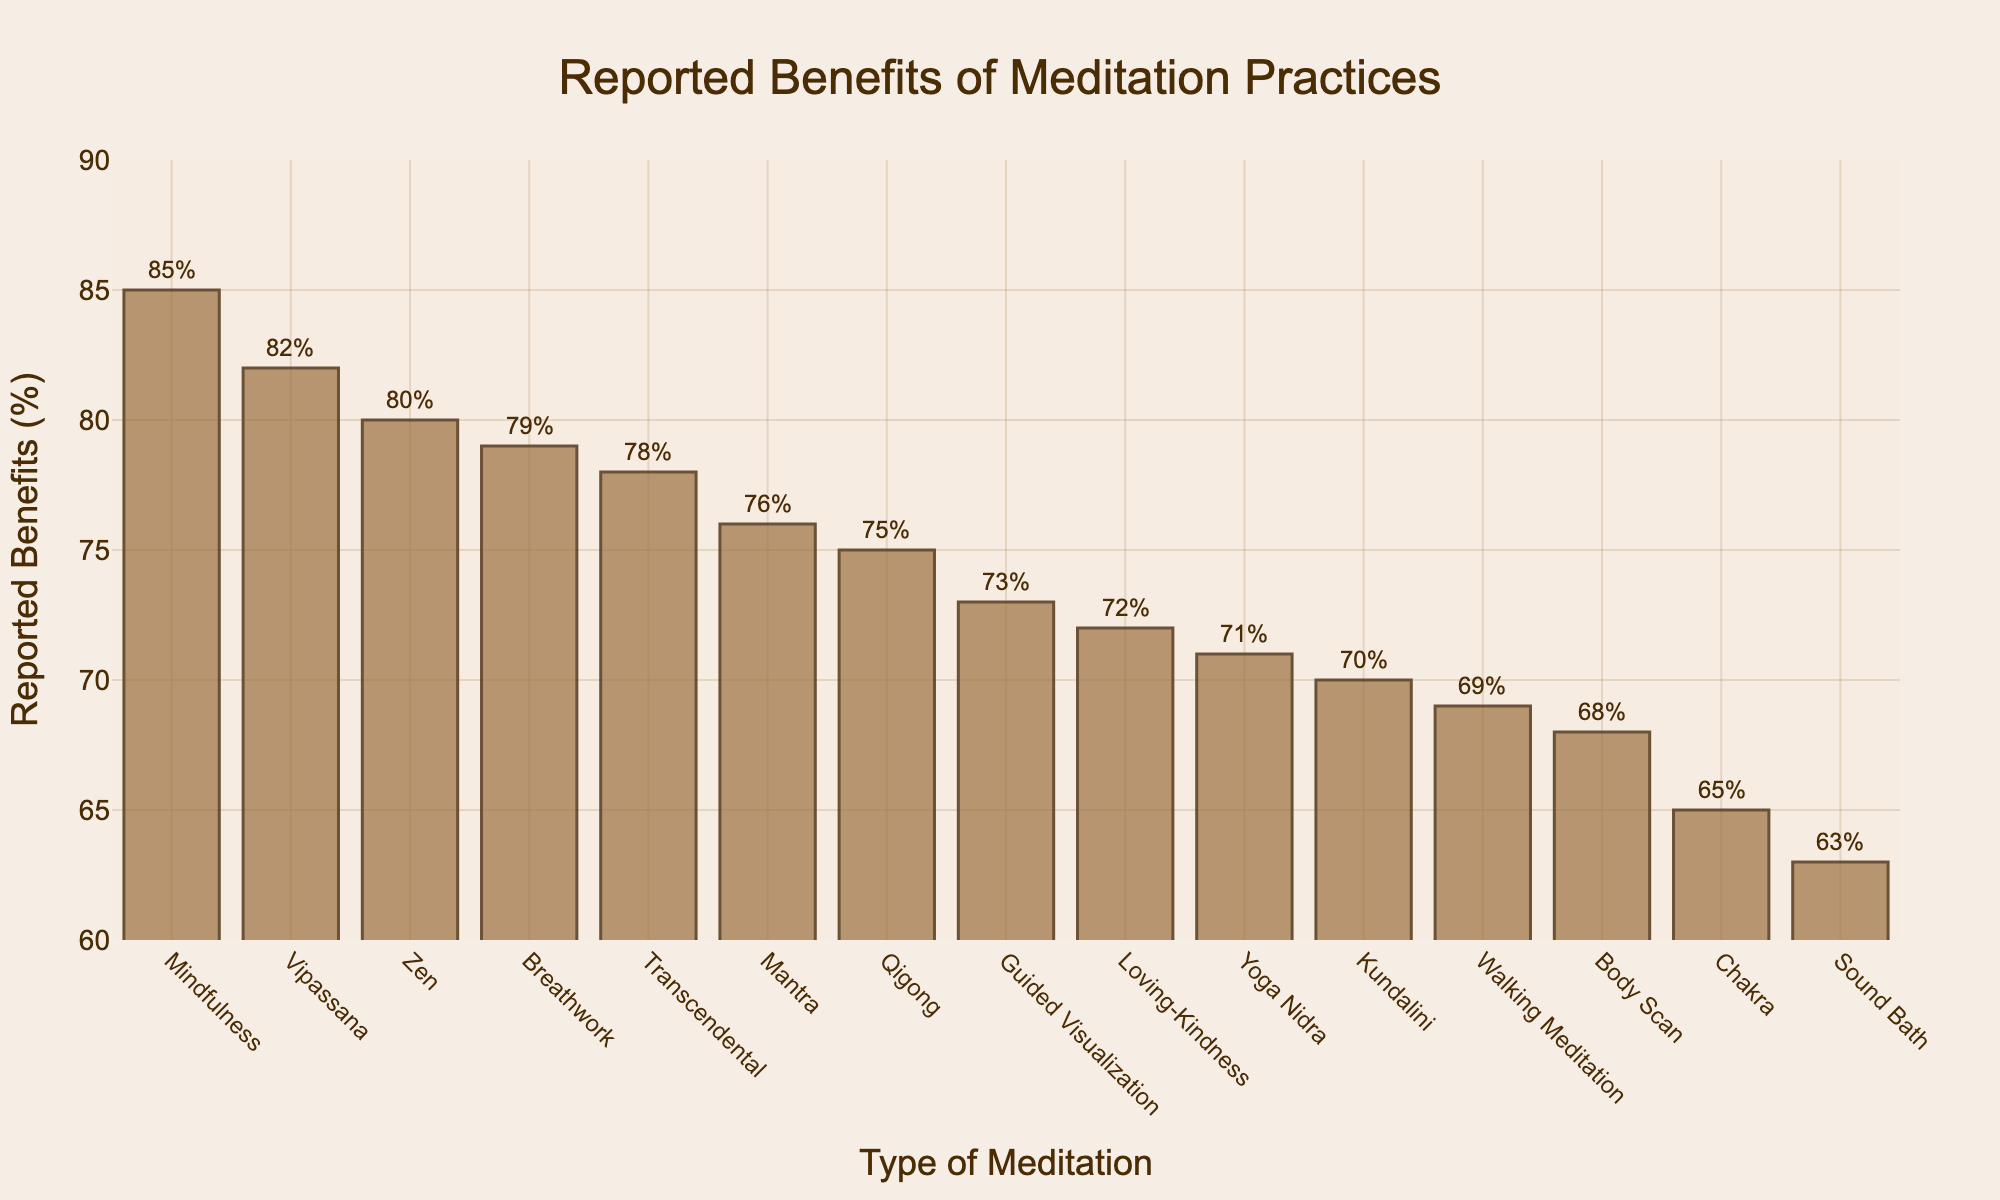Which type of meditation has the highest reported benefits? Look at the highest bar in the chart. The highest bar represents the "Mindfulness" meditation with 85% reported benefits.
Answer: Mindfulness Which type of meditation has the lowest reported benefits? Look at the shortest bar in the chart. The shortest bar represents the "Sound Bath" meditation with 63% reported benefits.
Answer: Sound Bath What is the approximate difference in reported benefits between the highest and lowest types of meditation? The highest reported benefits for "Mindfulness" is 85%, and the lowest for "Sound Bath" is 63%. The difference is 85% - 63% = 22%.
Answer: 22% How does the reported benefit of "Zen" compare to "Breathwork"? Check the bars for "Zen" and "Breathwork". "Zen" has 80% while "Breathwork" has 79%. "Zen" is higher by 1%.
Answer: Zen is higher by 1% What is the average reported benefit of the top three meditations? Identify the top three bars: "Mindfulness" (85%), "Vipassana" (82%), and "Zen" (80%). Calculate the average: (85 + 82 + 80) / 3 = 82.33%.
Answer: 82.33% Which type of meditation is reported to have similar benefits to "Walking Meditation"? "Walking Meditation" has 69% reported benefits. Look for bars close to this percentage. "Body Scan" has 68%, which is close.
Answer: Body Scan What is the combined reported benefit percentage of "Mantra" and "Chakra"? "Mantra" has 76% and "Chakra" has 65%. Add the percentages: 76 + 65 = 141%.
Answer: 141% Is the reported benefit of "Guided Visualization" higher or lower than the median reported benefit? Determine the middle value when the benefits are listed. The median for 15 values is the 8th highest, which is "Qigong" with 75%. "Guided Visualization" has 73%, so it is lower.
Answer: Lower How many types of meditation have a reported benefit of 70% or higher? Count the bars at 70% or above. These include "Mindfulness", "Transcendental", "Loving-Kindness", "Zen", "Vipassana", "Kundalini", "Qigong", "Guided Visualization", "Mantra", "Breathwork", and "Yoga Nidra". There are 11 types.
Answer: 11 What is the difference in the reported benefits between "Loving-Kindness" and "Guided Visualization"? "Loving-Kindness" has 72% and "Guided Visualization" has 73%. The difference is 73% - 72% = 1%.
Answer: 1% 